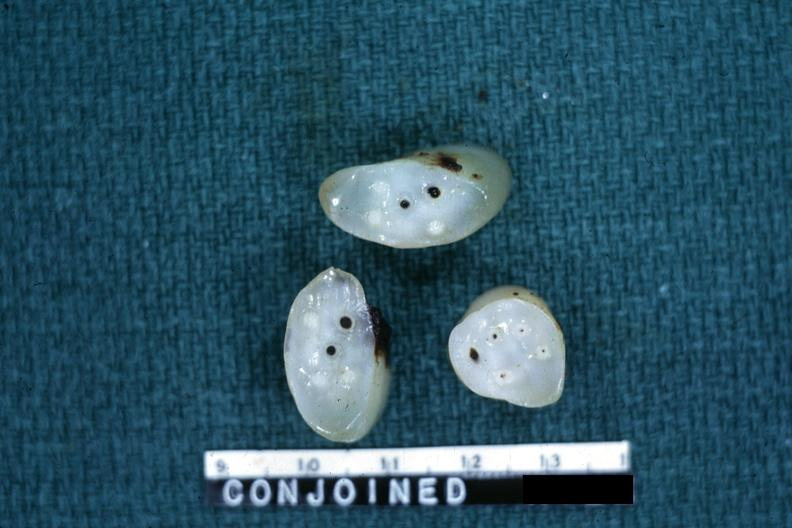s female reproductive present?
Answer the question using a single word or phrase. Yes 